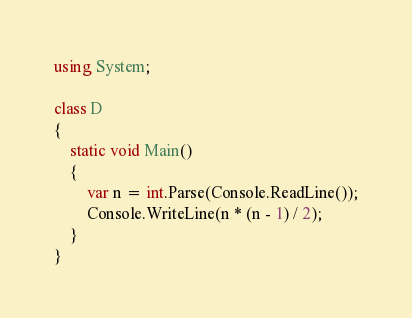Convert code to text. <code><loc_0><loc_0><loc_500><loc_500><_C#_>using System;

class D
{
	static void Main()
	{
		var n = int.Parse(Console.ReadLine());
		Console.WriteLine(n * (n - 1) / 2);
	}
}
</code> 